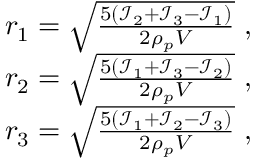Convert formula to latex. <formula><loc_0><loc_0><loc_500><loc_500>\begin{array} { r } { r _ { 1 } = \sqrt { \frac { 5 ( \mathcal { I } _ { 2 } + \mathcal { I } _ { 3 } - \mathcal { I } _ { 1 } ) } { 2 \rho _ { p } V } } \ , } \\ { r _ { 2 } = \sqrt { \frac { 5 ( \mathcal { I } _ { 1 } + \mathcal { I } _ { 3 } - \mathcal { I } _ { 2 } ) } { 2 \rho _ { p } V } } \ , } \\ { r _ { 3 } = \sqrt { \frac { 5 ( \mathcal { I } _ { 1 } + \mathcal { I } _ { 2 } - \mathcal { I } _ { 3 } ) } { 2 \rho _ { p } V } } \ , } \end{array}</formula> 